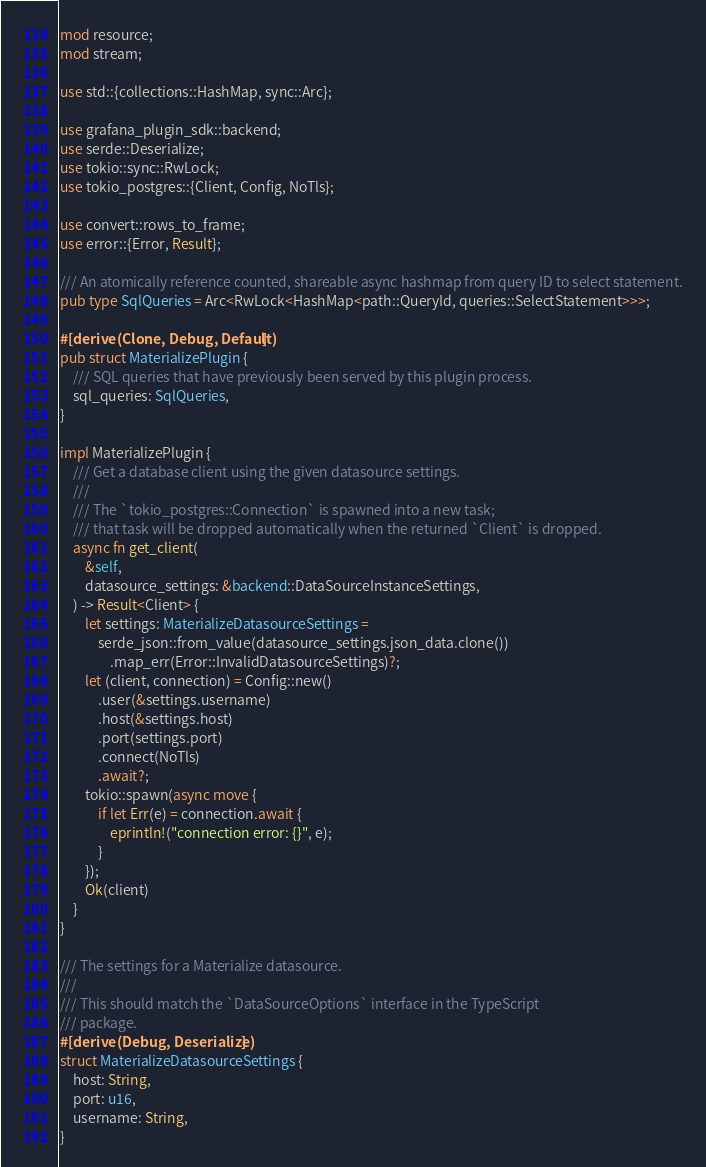Convert code to text. <code><loc_0><loc_0><loc_500><loc_500><_Rust_>mod resource;
mod stream;

use std::{collections::HashMap, sync::Arc};

use grafana_plugin_sdk::backend;
use serde::Deserialize;
use tokio::sync::RwLock;
use tokio_postgres::{Client, Config, NoTls};

use convert::rows_to_frame;
use error::{Error, Result};

/// An atomically reference counted, shareable async hashmap from query ID to select statement.
pub type SqlQueries = Arc<RwLock<HashMap<path::QueryId, queries::SelectStatement>>>;

#[derive(Clone, Debug, Default)]
pub struct MaterializePlugin {
    /// SQL queries that have previously been served by this plugin process.
    sql_queries: SqlQueries,
}

impl MaterializePlugin {
    /// Get a database client using the given datasource settings.
    ///
    /// The `tokio_postgres::Connection` is spawned into a new task;
    /// that task will be dropped automatically when the returned `Client` is dropped.
    async fn get_client(
        &self,
        datasource_settings: &backend::DataSourceInstanceSettings,
    ) -> Result<Client> {
        let settings: MaterializeDatasourceSettings =
            serde_json::from_value(datasource_settings.json_data.clone())
                .map_err(Error::InvalidDatasourceSettings)?;
        let (client, connection) = Config::new()
            .user(&settings.username)
            .host(&settings.host)
            .port(settings.port)
            .connect(NoTls)
            .await?;
        tokio::spawn(async move {
            if let Err(e) = connection.await {
                eprintln!("connection error: {}", e);
            }
        });
        Ok(client)
    }
}

/// The settings for a Materialize datasource.
///
/// This should match the `DataSourceOptions` interface in the TypeScript
/// package.
#[derive(Debug, Deserialize)]
struct MaterializeDatasourceSettings {
    host: String,
    port: u16,
    username: String,
}
</code> 